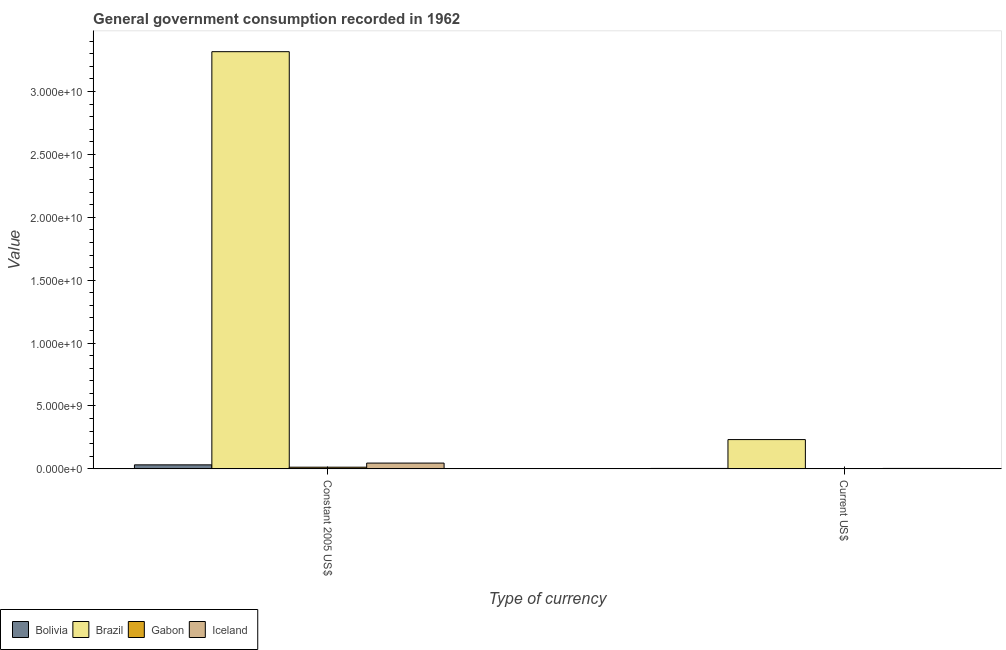How many groups of bars are there?
Give a very brief answer. 2. How many bars are there on the 1st tick from the left?
Give a very brief answer. 4. How many bars are there on the 2nd tick from the right?
Make the answer very short. 4. What is the label of the 1st group of bars from the left?
Your answer should be compact. Constant 2005 US$. What is the value consumed in constant 2005 us$ in Gabon?
Your response must be concise. 1.31e+08. Across all countries, what is the maximum value consumed in constant 2005 us$?
Ensure brevity in your answer.  3.32e+1. Across all countries, what is the minimum value consumed in current us$?
Offer a very short reply. 1.86e+07. In which country was the value consumed in current us$ maximum?
Your answer should be very brief. Brazil. In which country was the value consumed in current us$ minimum?
Provide a succinct answer. Gabon. What is the total value consumed in constant 2005 us$ in the graph?
Provide a succinct answer. 3.41e+1. What is the difference between the value consumed in current us$ in Brazil and that in Gabon?
Give a very brief answer. 2.31e+09. What is the difference between the value consumed in constant 2005 us$ in Gabon and the value consumed in current us$ in Iceland?
Give a very brief answer. 9.90e+07. What is the average value consumed in constant 2005 us$ per country?
Offer a very short reply. 8.52e+09. What is the difference between the value consumed in constant 2005 us$ and value consumed in current us$ in Bolivia?
Keep it short and to the point. 2.84e+08. In how many countries, is the value consumed in current us$ greater than 13000000000 ?
Your answer should be compact. 0. What is the ratio of the value consumed in constant 2005 us$ in Iceland to that in Bolivia?
Your response must be concise. 1.44. Is the value consumed in constant 2005 us$ in Bolivia less than that in Iceland?
Offer a terse response. Yes. What does the 2nd bar from the right in Constant 2005 US$ represents?
Offer a very short reply. Gabon. How many bars are there?
Offer a terse response. 8. Are all the bars in the graph horizontal?
Make the answer very short. No. Does the graph contain any zero values?
Make the answer very short. No. How many legend labels are there?
Your answer should be compact. 4. How are the legend labels stacked?
Offer a very short reply. Horizontal. What is the title of the graph?
Your answer should be very brief. General government consumption recorded in 1962. Does "Namibia" appear as one of the legend labels in the graph?
Keep it short and to the point. No. What is the label or title of the X-axis?
Make the answer very short. Type of currency. What is the label or title of the Y-axis?
Make the answer very short. Value. What is the Value of Bolivia in Constant 2005 US$?
Your answer should be very brief. 3.18e+08. What is the Value of Brazil in Constant 2005 US$?
Your answer should be very brief. 3.32e+1. What is the Value of Gabon in Constant 2005 US$?
Give a very brief answer. 1.31e+08. What is the Value of Iceland in Constant 2005 US$?
Give a very brief answer. 4.58e+08. What is the Value of Bolivia in Current US$?
Your answer should be compact. 3.34e+07. What is the Value in Brazil in Current US$?
Your response must be concise. 2.33e+09. What is the Value of Gabon in Current US$?
Make the answer very short. 1.86e+07. What is the Value of Iceland in Current US$?
Your answer should be compact. 3.25e+07. Across all Type of currency, what is the maximum Value in Bolivia?
Provide a short and direct response. 3.18e+08. Across all Type of currency, what is the maximum Value of Brazil?
Keep it short and to the point. 3.32e+1. Across all Type of currency, what is the maximum Value in Gabon?
Offer a terse response. 1.31e+08. Across all Type of currency, what is the maximum Value in Iceland?
Ensure brevity in your answer.  4.58e+08. Across all Type of currency, what is the minimum Value in Bolivia?
Make the answer very short. 3.34e+07. Across all Type of currency, what is the minimum Value in Brazil?
Your response must be concise. 2.33e+09. Across all Type of currency, what is the minimum Value of Gabon?
Offer a very short reply. 1.86e+07. Across all Type of currency, what is the minimum Value of Iceland?
Make the answer very short. 3.25e+07. What is the total Value in Bolivia in the graph?
Give a very brief answer. 3.51e+08. What is the total Value of Brazil in the graph?
Make the answer very short. 3.55e+1. What is the total Value of Gabon in the graph?
Your response must be concise. 1.50e+08. What is the total Value of Iceland in the graph?
Make the answer very short. 4.90e+08. What is the difference between the Value of Bolivia in Constant 2005 US$ and that in Current US$?
Offer a terse response. 2.84e+08. What is the difference between the Value of Brazil in Constant 2005 US$ and that in Current US$?
Your response must be concise. 3.08e+1. What is the difference between the Value in Gabon in Constant 2005 US$ and that in Current US$?
Give a very brief answer. 1.13e+08. What is the difference between the Value of Iceland in Constant 2005 US$ and that in Current US$?
Your response must be concise. 4.25e+08. What is the difference between the Value of Bolivia in Constant 2005 US$ and the Value of Brazil in Current US$?
Keep it short and to the point. -2.01e+09. What is the difference between the Value of Bolivia in Constant 2005 US$ and the Value of Gabon in Current US$?
Keep it short and to the point. 2.99e+08. What is the difference between the Value of Bolivia in Constant 2005 US$ and the Value of Iceland in Current US$?
Give a very brief answer. 2.85e+08. What is the difference between the Value of Brazil in Constant 2005 US$ and the Value of Gabon in Current US$?
Ensure brevity in your answer.  3.32e+1. What is the difference between the Value of Brazil in Constant 2005 US$ and the Value of Iceland in Current US$?
Offer a very short reply. 3.31e+1. What is the difference between the Value of Gabon in Constant 2005 US$ and the Value of Iceland in Current US$?
Your answer should be very brief. 9.90e+07. What is the average Value of Bolivia per Type of currency?
Provide a succinct answer. 1.76e+08. What is the average Value of Brazil per Type of currency?
Ensure brevity in your answer.  1.77e+1. What is the average Value of Gabon per Type of currency?
Make the answer very short. 7.51e+07. What is the average Value of Iceland per Type of currency?
Keep it short and to the point. 2.45e+08. What is the difference between the Value of Bolivia and Value of Brazil in Constant 2005 US$?
Give a very brief answer. -3.29e+1. What is the difference between the Value in Bolivia and Value in Gabon in Constant 2005 US$?
Offer a terse response. 1.86e+08. What is the difference between the Value in Bolivia and Value in Iceland in Constant 2005 US$?
Offer a very short reply. -1.40e+08. What is the difference between the Value of Brazil and Value of Gabon in Constant 2005 US$?
Your answer should be very brief. 3.30e+1. What is the difference between the Value of Brazil and Value of Iceland in Constant 2005 US$?
Ensure brevity in your answer.  3.27e+1. What is the difference between the Value in Gabon and Value in Iceland in Constant 2005 US$?
Give a very brief answer. -3.26e+08. What is the difference between the Value in Bolivia and Value in Brazil in Current US$?
Give a very brief answer. -2.29e+09. What is the difference between the Value of Bolivia and Value of Gabon in Current US$?
Your response must be concise. 1.47e+07. What is the difference between the Value in Bolivia and Value in Iceland in Current US$?
Offer a terse response. 8.57e+05. What is the difference between the Value of Brazil and Value of Gabon in Current US$?
Offer a terse response. 2.31e+09. What is the difference between the Value of Brazil and Value of Iceland in Current US$?
Your answer should be very brief. 2.29e+09. What is the difference between the Value in Gabon and Value in Iceland in Current US$?
Provide a succinct answer. -1.39e+07. What is the ratio of the Value of Bolivia in Constant 2005 US$ to that in Current US$?
Provide a succinct answer. 9.51. What is the ratio of the Value in Brazil in Constant 2005 US$ to that in Current US$?
Offer a terse response. 14.26. What is the ratio of the Value in Gabon in Constant 2005 US$ to that in Current US$?
Offer a very short reply. 7.05. What is the ratio of the Value in Iceland in Constant 2005 US$ to that in Current US$?
Give a very brief answer. 14.07. What is the difference between the highest and the second highest Value in Bolivia?
Keep it short and to the point. 2.84e+08. What is the difference between the highest and the second highest Value of Brazil?
Your response must be concise. 3.08e+1. What is the difference between the highest and the second highest Value of Gabon?
Your answer should be compact. 1.13e+08. What is the difference between the highest and the second highest Value of Iceland?
Provide a short and direct response. 4.25e+08. What is the difference between the highest and the lowest Value of Bolivia?
Provide a short and direct response. 2.84e+08. What is the difference between the highest and the lowest Value of Brazil?
Ensure brevity in your answer.  3.08e+1. What is the difference between the highest and the lowest Value of Gabon?
Give a very brief answer. 1.13e+08. What is the difference between the highest and the lowest Value in Iceland?
Ensure brevity in your answer.  4.25e+08. 